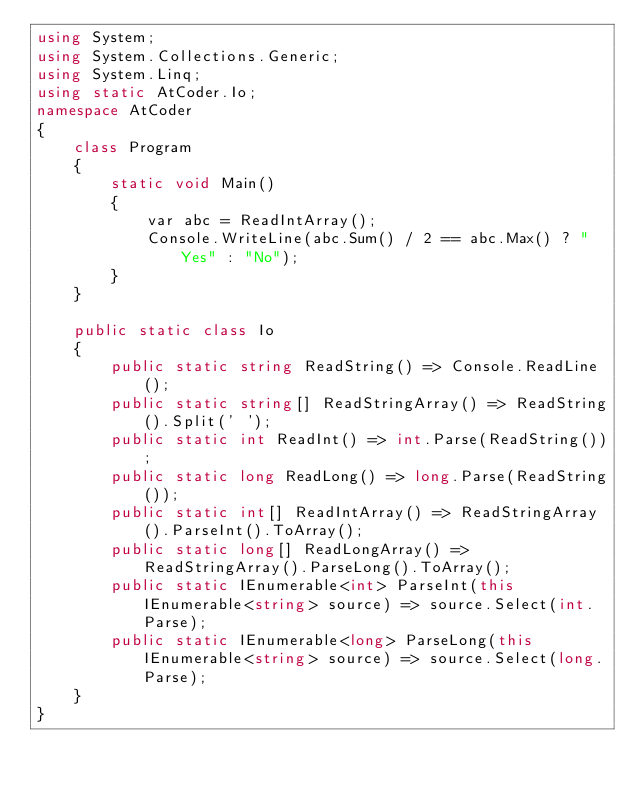Convert code to text. <code><loc_0><loc_0><loc_500><loc_500><_C#_>using System;
using System.Collections.Generic;
using System.Linq;
using static AtCoder.Io;
namespace AtCoder
{
    class Program
    {
        static void Main()
        {
            var abc = ReadIntArray();
            Console.WriteLine(abc.Sum() / 2 == abc.Max() ? "Yes" : "No");
        }
    }

    public static class Io
    {
        public static string ReadString() => Console.ReadLine();
        public static string[] ReadStringArray() => ReadString().Split(' ');
        public static int ReadInt() => int.Parse(ReadString());
        public static long ReadLong() => long.Parse(ReadString());
        public static int[] ReadIntArray() => ReadStringArray().ParseInt().ToArray();
        public static long[] ReadLongArray() => ReadStringArray().ParseLong().ToArray();
        public static IEnumerable<int> ParseInt(this IEnumerable<string> source) => source.Select(int.Parse);
        public static IEnumerable<long> ParseLong(this IEnumerable<string> source) => source.Select(long.Parse);
    }
}
</code> 